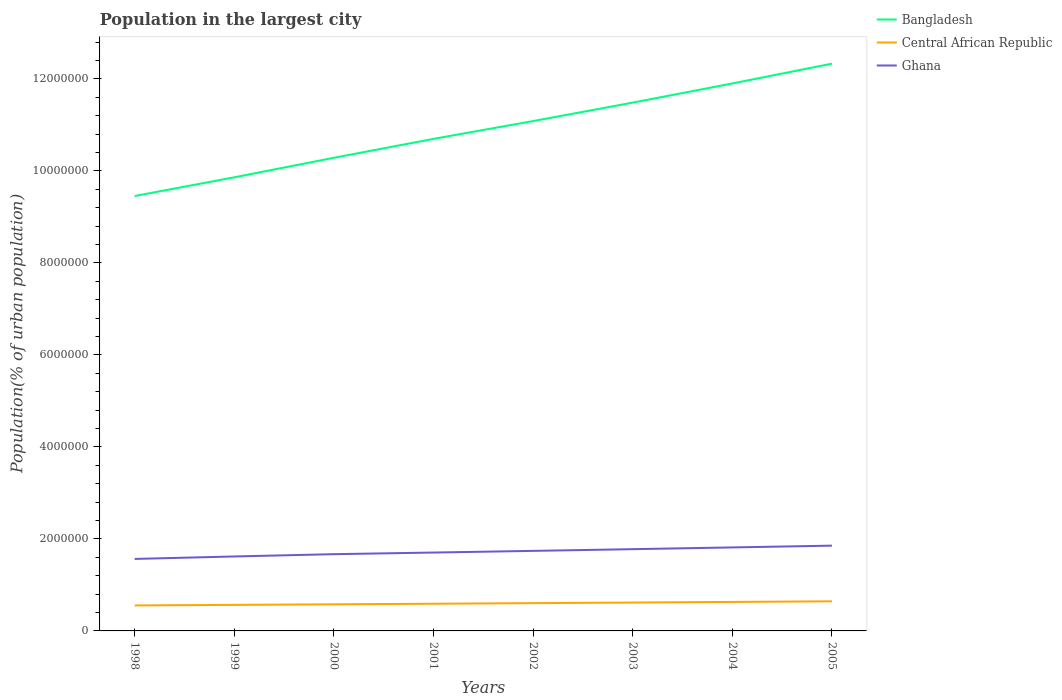How many different coloured lines are there?
Your answer should be very brief. 3. Across all years, what is the maximum population in the largest city in Central African Republic?
Offer a very short reply. 5.54e+05. In which year was the population in the largest city in Bangladesh maximum?
Offer a very short reply. 1998. What is the total population in the largest city in Bangladesh in the graph?
Your response must be concise. -4.01e+05. What is the difference between the highest and the second highest population in the largest city in Ghana?
Provide a short and direct response. 2.89e+05. What is the difference between the highest and the lowest population in the largest city in Bangladesh?
Ensure brevity in your answer.  4. Is the population in the largest city in Ghana strictly greater than the population in the largest city in Bangladesh over the years?
Your response must be concise. Yes. How many lines are there?
Provide a short and direct response. 3. What is the difference between two consecutive major ticks on the Y-axis?
Offer a very short reply. 2.00e+06. How many legend labels are there?
Provide a succinct answer. 3. How are the legend labels stacked?
Provide a succinct answer. Vertical. What is the title of the graph?
Give a very brief answer. Population in the largest city. What is the label or title of the Y-axis?
Make the answer very short. Population(% of urban population). What is the Population(% of urban population) of Bangladesh in 1998?
Ensure brevity in your answer.  9.45e+06. What is the Population(% of urban population) of Central African Republic in 1998?
Your response must be concise. 5.54e+05. What is the Population(% of urban population) in Ghana in 1998?
Provide a succinct answer. 1.57e+06. What is the Population(% of urban population) in Bangladesh in 1999?
Provide a short and direct response. 9.86e+06. What is the Population(% of urban population) of Central African Republic in 1999?
Your answer should be very brief. 5.66e+05. What is the Population(% of urban population) of Ghana in 1999?
Offer a very short reply. 1.62e+06. What is the Population(% of urban population) of Bangladesh in 2000?
Offer a very short reply. 1.03e+07. What is the Population(% of urban population) in Central African Republic in 2000?
Your answer should be very brief. 5.79e+05. What is the Population(% of urban population) in Ghana in 2000?
Your answer should be compact. 1.67e+06. What is the Population(% of urban population) in Bangladesh in 2001?
Provide a succinct answer. 1.07e+07. What is the Population(% of urban population) of Central African Republic in 2001?
Your answer should be very brief. 5.91e+05. What is the Population(% of urban population) in Ghana in 2001?
Provide a succinct answer. 1.70e+06. What is the Population(% of urban population) of Bangladesh in 2002?
Give a very brief answer. 1.11e+07. What is the Population(% of urban population) in Central African Republic in 2002?
Provide a short and direct response. 6.04e+05. What is the Population(% of urban population) of Ghana in 2002?
Ensure brevity in your answer.  1.74e+06. What is the Population(% of urban population) of Bangladesh in 2003?
Offer a very short reply. 1.15e+07. What is the Population(% of urban population) of Central African Republic in 2003?
Your answer should be very brief. 6.17e+05. What is the Population(% of urban population) of Ghana in 2003?
Keep it short and to the point. 1.78e+06. What is the Population(% of urban population) in Bangladesh in 2004?
Make the answer very short. 1.19e+07. What is the Population(% of urban population) in Central African Republic in 2004?
Your response must be concise. 6.30e+05. What is the Population(% of urban population) of Ghana in 2004?
Offer a terse response. 1.82e+06. What is the Population(% of urban population) of Bangladesh in 2005?
Provide a short and direct response. 1.23e+07. What is the Population(% of urban population) in Central African Republic in 2005?
Ensure brevity in your answer.  6.44e+05. What is the Population(% of urban population) in Ghana in 2005?
Offer a terse response. 1.85e+06. Across all years, what is the maximum Population(% of urban population) in Bangladesh?
Provide a succinct answer. 1.23e+07. Across all years, what is the maximum Population(% of urban population) in Central African Republic?
Your response must be concise. 6.44e+05. Across all years, what is the maximum Population(% of urban population) of Ghana?
Give a very brief answer. 1.85e+06. Across all years, what is the minimum Population(% of urban population) in Bangladesh?
Your answer should be compact. 9.45e+06. Across all years, what is the minimum Population(% of urban population) of Central African Republic?
Provide a succinct answer. 5.54e+05. Across all years, what is the minimum Population(% of urban population) of Ghana?
Give a very brief answer. 1.57e+06. What is the total Population(% of urban population) of Bangladesh in the graph?
Your response must be concise. 8.71e+07. What is the total Population(% of urban population) of Central African Republic in the graph?
Provide a succinct answer. 4.79e+06. What is the total Population(% of urban population) of Ghana in the graph?
Your answer should be very brief. 1.37e+07. What is the difference between the Population(% of urban population) of Bangladesh in 1998 and that in 1999?
Your answer should be compact. -4.06e+05. What is the difference between the Population(% of urban population) of Central African Republic in 1998 and that in 1999?
Your answer should be compact. -1.20e+04. What is the difference between the Population(% of urban population) of Ghana in 1998 and that in 1999?
Provide a short and direct response. -5.33e+04. What is the difference between the Population(% of urban population) of Bangladesh in 1998 and that in 2000?
Provide a succinct answer. -8.31e+05. What is the difference between the Population(% of urban population) of Central African Republic in 1998 and that in 2000?
Your answer should be compact. -2.43e+04. What is the difference between the Population(% of urban population) in Ghana in 1998 and that in 2000?
Offer a very short reply. -1.03e+05. What is the difference between the Population(% of urban population) of Bangladesh in 1998 and that in 2001?
Your answer should be compact. -1.24e+06. What is the difference between the Population(% of urban population) of Central African Republic in 1998 and that in 2001?
Ensure brevity in your answer.  -3.68e+04. What is the difference between the Population(% of urban population) in Ghana in 1998 and that in 2001?
Make the answer very short. -1.39e+05. What is the difference between the Population(% of urban population) of Bangladesh in 1998 and that in 2002?
Your response must be concise. -1.63e+06. What is the difference between the Population(% of urban population) in Central African Republic in 1998 and that in 2002?
Give a very brief answer. -4.96e+04. What is the difference between the Population(% of urban population) of Ghana in 1998 and that in 2002?
Offer a terse response. -1.75e+05. What is the difference between the Population(% of urban population) in Bangladesh in 1998 and that in 2003?
Make the answer very short. -2.03e+06. What is the difference between the Population(% of urban population) of Central African Republic in 1998 and that in 2003?
Provide a short and direct response. -6.27e+04. What is the difference between the Population(% of urban population) in Ghana in 1998 and that in 2003?
Provide a succinct answer. -2.12e+05. What is the difference between the Population(% of urban population) of Bangladesh in 1998 and that in 2004?
Provide a short and direct response. -2.45e+06. What is the difference between the Population(% of urban population) in Central African Republic in 1998 and that in 2004?
Keep it short and to the point. -7.61e+04. What is the difference between the Population(% of urban population) in Ghana in 1998 and that in 2004?
Keep it short and to the point. -2.50e+05. What is the difference between the Population(% of urban population) in Bangladesh in 1998 and that in 2005?
Your answer should be compact. -2.88e+06. What is the difference between the Population(% of urban population) in Central African Republic in 1998 and that in 2005?
Offer a terse response. -8.97e+04. What is the difference between the Population(% of urban population) in Ghana in 1998 and that in 2005?
Offer a terse response. -2.89e+05. What is the difference between the Population(% of urban population) in Bangladesh in 1999 and that in 2000?
Keep it short and to the point. -4.25e+05. What is the difference between the Population(% of urban population) in Central African Republic in 1999 and that in 2000?
Offer a terse response. -1.23e+04. What is the difference between the Population(% of urban population) in Ghana in 1999 and that in 2000?
Provide a short and direct response. -4.97e+04. What is the difference between the Population(% of urban population) of Bangladesh in 1999 and that in 2001?
Your response must be concise. -8.35e+05. What is the difference between the Population(% of urban population) in Central African Republic in 1999 and that in 2001?
Provide a succinct answer. -2.48e+04. What is the difference between the Population(% of urban population) in Ghana in 1999 and that in 2001?
Provide a succinct answer. -8.53e+04. What is the difference between the Population(% of urban population) in Bangladesh in 1999 and that in 2002?
Your answer should be compact. -1.22e+06. What is the difference between the Population(% of urban population) of Central African Republic in 1999 and that in 2002?
Ensure brevity in your answer.  -3.76e+04. What is the difference between the Population(% of urban population) in Ghana in 1999 and that in 2002?
Provide a short and direct response. -1.22e+05. What is the difference between the Population(% of urban population) in Bangladesh in 1999 and that in 2003?
Ensure brevity in your answer.  -1.62e+06. What is the difference between the Population(% of urban population) of Central African Republic in 1999 and that in 2003?
Ensure brevity in your answer.  -5.07e+04. What is the difference between the Population(% of urban population) in Ghana in 1999 and that in 2003?
Keep it short and to the point. -1.59e+05. What is the difference between the Population(% of urban population) of Bangladesh in 1999 and that in 2004?
Your response must be concise. -2.04e+06. What is the difference between the Population(% of urban population) of Central African Republic in 1999 and that in 2004?
Provide a short and direct response. -6.41e+04. What is the difference between the Population(% of urban population) in Ghana in 1999 and that in 2004?
Make the answer very short. -1.97e+05. What is the difference between the Population(% of urban population) in Bangladesh in 1999 and that in 2005?
Give a very brief answer. -2.47e+06. What is the difference between the Population(% of urban population) in Central African Republic in 1999 and that in 2005?
Provide a short and direct response. -7.77e+04. What is the difference between the Population(% of urban population) of Ghana in 1999 and that in 2005?
Your answer should be very brief. -2.35e+05. What is the difference between the Population(% of urban population) of Bangladesh in 2000 and that in 2001?
Your answer should be very brief. -4.11e+05. What is the difference between the Population(% of urban population) in Central African Republic in 2000 and that in 2001?
Your response must be concise. -1.25e+04. What is the difference between the Population(% of urban population) in Ghana in 2000 and that in 2001?
Offer a very short reply. -3.55e+04. What is the difference between the Population(% of urban population) of Bangladesh in 2000 and that in 2002?
Your answer should be very brief. -7.98e+05. What is the difference between the Population(% of urban population) in Central African Republic in 2000 and that in 2002?
Provide a succinct answer. -2.53e+04. What is the difference between the Population(% of urban population) of Ghana in 2000 and that in 2002?
Offer a terse response. -7.19e+04. What is the difference between the Population(% of urban population) of Bangladesh in 2000 and that in 2003?
Keep it short and to the point. -1.20e+06. What is the difference between the Population(% of urban population) of Central African Republic in 2000 and that in 2003?
Make the answer very short. -3.84e+04. What is the difference between the Population(% of urban population) in Ghana in 2000 and that in 2003?
Your response must be concise. -1.09e+05. What is the difference between the Population(% of urban population) of Bangladesh in 2000 and that in 2004?
Your answer should be compact. -1.62e+06. What is the difference between the Population(% of urban population) of Central African Republic in 2000 and that in 2004?
Offer a terse response. -5.18e+04. What is the difference between the Population(% of urban population) in Ghana in 2000 and that in 2004?
Your answer should be compact. -1.47e+05. What is the difference between the Population(% of urban population) of Bangladesh in 2000 and that in 2005?
Your answer should be compact. -2.05e+06. What is the difference between the Population(% of urban population) of Central African Republic in 2000 and that in 2005?
Your answer should be compact. -6.54e+04. What is the difference between the Population(% of urban population) in Ghana in 2000 and that in 2005?
Offer a very short reply. -1.86e+05. What is the difference between the Population(% of urban population) of Bangladesh in 2001 and that in 2002?
Offer a terse response. -3.87e+05. What is the difference between the Population(% of urban population) in Central African Republic in 2001 and that in 2002?
Offer a terse response. -1.28e+04. What is the difference between the Population(% of urban population) in Ghana in 2001 and that in 2002?
Keep it short and to the point. -3.63e+04. What is the difference between the Population(% of urban population) of Bangladesh in 2001 and that in 2003?
Offer a terse response. -7.88e+05. What is the difference between the Population(% of urban population) of Central African Republic in 2001 and that in 2003?
Offer a terse response. -2.59e+04. What is the difference between the Population(% of urban population) in Ghana in 2001 and that in 2003?
Ensure brevity in your answer.  -7.34e+04. What is the difference between the Population(% of urban population) of Bangladesh in 2001 and that in 2004?
Offer a terse response. -1.20e+06. What is the difference between the Population(% of urban population) of Central African Republic in 2001 and that in 2004?
Your response must be concise. -3.93e+04. What is the difference between the Population(% of urban population) in Ghana in 2001 and that in 2004?
Your response must be concise. -1.11e+05. What is the difference between the Population(% of urban population) in Bangladesh in 2001 and that in 2005?
Offer a terse response. -1.64e+06. What is the difference between the Population(% of urban population) of Central African Republic in 2001 and that in 2005?
Provide a short and direct response. -5.29e+04. What is the difference between the Population(% of urban population) in Ghana in 2001 and that in 2005?
Your answer should be very brief. -1.50e+05. What is the difference between the Population(% of urban population) of Bangladesh in 2002 and that in 2003?
Provide a short and direct response. -4.01e+05. What is the difference between the Population(% of urban population) in Central African Republic in 2002 and that in 2003?
Offer a terse response. -1.31e+04. What is the difference between the Population(% of urban population) in Ghana in 2002 and that in 2003?
Keep it short and to the point. -3.71e+04. What is the difference between the Population(% of urban population) in Bangladesh in 2002 and that in 2004?
Your answer should be very brief. -8.18e+05. What is the difference between the Population(% of urban population) in Central African Republic in 2002 and that in 2004?
Offer a very short reply. -2.65e+04. What is the difference between the Population(% of urban population) of Ghana in 2002 and that in 2004?
Ensure brevity in your answer.  -7.51e+04. What is the difference between the Population(% of urban population) in Bangladesh in 2002 and that in 2005?
Provide a short and direct response. -1.25e+06. What is the difference between the Population(% of urban population) of Central African Republic in 2002 and that in 2005?
Give a very brief answer. -4.01e+04. What is the difference between the Population(% of urban population) in Ghana in 2002 and that in 2005?
Keep it short and to the point. -1.14e+05. What is the difference between the Population(% of urban population) of Bangladesh in 2003 and that in 2004?
Your answer should be very brief. -4.16e+05. What is the difference between the Population(% of urban population) in Central African Republic in 2003 and that in 2004?
Offer a terse response. -1.34e+04. What is the difference between the Population(% of urban population) of Ghana in 2003 and that in 2004?
Offer a terse response. -3.80e+04. What is the difference between the Population(% of urban population) of Bangladesh in 2003 and that in 2005?
Offer a very short reply. -8.47e+05. What is the difference between the Population(% of urban population) of Central African Republic in 2003 and that in 2005?
Your response must be concise. -2.70e+04. What is the difference between the Population(% of urban population) in Ghana in 2003 and that in 2005?
Your answer should be very brief. -7.66e+04. What is the difference between the Population(% of urban population) in Bangladesh in 2004 and that in 2005?
Offer a very short reply. -4.30e+05. What is the difference between the Population(% of urban population) in Central African Republic in 2004 and that in 2005?
Your answer should be compact. -1.36e+04. What is the difference between the Population(% of urban population) in Ghana in 2004 and that in 2005?
Make the answer very short. -3.87e+04. What is the difference between the Population(% of urban population) of Bangladesh in 1998 and the Population(% of urban population) of Central African Republic in 1999?
Make the answer very short. 8.89e+06. What is the difference between the Population(% of urban population) in Bangladesh in 1998 and the Population(% of urban population) in Ghana in 1999?
Give a very brief answer. 7.84e+06. What is the difference between the Population(% of urban population) in Central African Republic in 1998 and the Population(% of urban population) in Ghana in 1999?
Offer a terse response. -1.06e+06. What is the difference between the Population(% of urban population) in Bangladesh in 1998 and the Population(% of urban population) in Central African Republic in 2000?
Offer a very short reply. 8.88e+06. What is the difference between the Population(% of urban population) of Bangladesh in 1998 and the Population(% of urban population) of Ghana in 2000?
Your answer should be very brief. 7.79e+06. What is the difference between the Population(% of urban population) in Central African Republic in 1998 and the Population(% of urban population) in Ghana in 2000?
Ensure brevity in your answer.  -1.11e+06. What is the difference between the Population(% of urban population) in Bangladesh in 1998 and the Population(% of urban population) in Central African Republic in 2001?
Ensure brevity in your answer.  8.86e+06. What is the difference between the Population(% of urban population) in Bangladesh in 1998 and the Population(% of urban population) in Ghana in 2001?
Give a very brief answer. 7.75e+06. What is the difference between the Population(% of urban population) in Central African Republic in 1998 and the Population(% of urban population) in Ghana in 2001?
Give a very brief answer. -1.15e+06. What is the difference between the Population(% of urban population) in Bangladesh in 1998 and the Population(% of urban population) in Central African Republic in 2002?
Make the answer very short. 8.85e+06. What is the difference between the Population(% of urban population) in Bangladesh in 1998 and the Population(% of urban population) in Ghana in 2002?
Give a very brief answer. 7.71e+06. What is the difference between the Population(% of urban population) in Central African Republic in 1998 and the Population(% of urban population) in Ghana in 2002?
Offer a terse response. -1.19e+06. What is the difference between the Population(% of urban population) of Bangladesh in 1998 and the Population(% of urban population) of Central African Republic in 2003?
Give a very brief answer. 8.84e+06. What is the difference between the Population(% of urban population) of Bangladesh in 1998 and the Population(% of urban population) of Ghana in 2003?
Your answer should be very brief. 7.68e+06. What is the difference between the Population(% of urban population) of Central African Republic in 1998 and the Population(% of urban population) of Ghana in 2003?
Your answer should be compact. -1.22e+06. What is the difference between the Population(% of urban population) in Bangladesh in 1998 and the Population(% of urban population) in Central African Republic in 2004?
Provide a succinct answer. 8.82e+06. What is the difference between the Population(% of urban population) in Bangladesh in 1998 and the Population(% of urban population) in Ghana in 2004?
Provide a short and direct response. 7.64e+06. What is the difference between the Population(% of urban population) in Central African Republic in 1998 and the Population(% of urban population) in Ghana in 2004?
Your response must be concise. -1.26e+06. What is the difference between the Population(% of urban population) in Bangladesh in 1998 and the Population(% of urban population) in Central African Republic in 2005?
Keep it short and to the point. 8.81e+06. What is the difference between the Population(% of urban population) of Bangladesh in 1998 and the Population(% of urban population) of Ghana in 2005?
Ensure brevity in your answer.  7.60e+06. What is the difference between the Population(% of urban population) in Central African Republic in 1998 and the Population(% of urban population) in Ghana in 2005?
Provide a succinct answer. -1.30e+06. What is the difference between the Population(% of urban population) in Bangladesh in 1999 and the Population(% of urban population) in Central African Republic in 2000?
Your answer should be very brief. 9.28e+06. What is the difference between the Population(% of urban population) of Bangladesh in 1999 and the Population(% of urban population) of Ghana in 2000?
Your answer should be very brief. 8.19e+06. What is the difference between the Population(% of urban population) in Central African Republic in 1999 and the Population(% of urban population) in Ghana in 2000?
Offer a very short reply. -1.10e+06. What is the difference between the Population(% of urban population) of Bangladesh in 1999 and the Population(% of urban population) of Central African Republic in 2001?
Keep it short and to the point. 9.27e+06. What is the difference between the Population(% of urban population) of Bangladesh in 1999 and the Population(% of urban population) of Ghana in 2001?
Your response must be concise. 8.16e+06. What is the difference between the Population(% of urban population) in Central African Republic in 1999 and the Population(% of urban population) in Ghana in 2001?
Your response must be concise. -1.14e+06. What is the difference between the Population(% of urban population) of Bangladesh in 1999 and the Population(% of urban population) of Central African Republic in 2002?
Your answer should be compact. 9.26e+06. What is the difference between the Population(% of urban population) in Bangladesh in 1999 and the Population(% of urban population) in Ghana in 2002?
Your answer should be compact. 8.12e+06. What is the difference between the Population(% of urban population) of Central African Republic in 1999 and the Population(% of urban population) of Ghana in 2002?
Provide a short and direct response. -1.17e+06. What is the difference between the Population(% of urban population) in Bangladesh in 1999 and the Population(% of urban population) in Central African Republic in 2003?
Ensure brevity in your answer.  9.24e+06. What is the difference between the Population(% of urban population) of Bangladesh in 1999 and the Population(% of urban population) of Ghana in 2003?
Provide a short and direct response. 8.08e+06. What is the difference between the Population(% of urban population) of Central African Republic in 1999 and the Population(% of urban population) of Ghana in 2003?
Your answer should be compact. -1.21e+06. What is the difference between the Population(% of urban population) of Bangladesh in 1999 and the Population(% of urban population) of Central African Republic in 2004?
Your answer should be very brief. 9.23e+06. What is the difference between the Population(% of urban population) in Bangladesh in 1999 and the Population(% of urban population) in Ghana in 2004?
Your answer should be very brief. 8.05e+06. What is the difference between the Population(% of urban population) in Central African Republic in 1999 and the Population(% of urban population) in Ghana in 2004?
Make the answer very short. -1.25e+06. What is the difference between the Population(% of urban population) of Bangladesh in 1999 and the Population(% of urban population) of Central African Republic in 2005?
Give a very brief answer. 9.22e+06. What is the difference between the Population(% of urban population) of Bangladesh in 1999 and the Population(% of urban population) of Ghana in 2005?
Keep it short and to the point. 8.01e+06. What is the difference between the Population(% of urban population) of Central African Republic in 1999 and the Population(% of urban population) of Ghana in 2005?
Make the answer very short. -1.29e+06. What is the difference between the Population(% of urban population) of Bangladesh in 2000 and the Population(% of urban population) of Central African Republic in 2001?
Give a very brief answer. 9.69e+06. What is the difference between the Population(% of urban population) of Bangladesh in 2000 and the Population(% of urban population) of Ghana in 2001?
Offer a terse response. 8.58e+06. What is the difference between the Population(% of urban population) of Central African Republic in 2000 and the Population(% of urban population) of Ghana in 2001?
Give a very brief answer. -1.13e+06. What is the difference between the Population(% of urban population) in Bangladesh in 2000 and the Population(% of urban population) in Central African Republic in 2002?
Provide a succinct answer. 9.68e+06. What is the difference between the Population(% of urban population) in Bangladesh in 2000 and the Population(% of urban population) in Ghana in 2002?
Provide a succinct answer. 8.54e+06. What is the difference between the Population(% of urban population) in Central African Republic in 2000 and the Population(% of urban population) in Ghana in 2002?
Offer a terse response. -1.16e+06. What is the difference between the Population(% of urban population) of Bangladesh in 2000 and the Population(% of urban population) of Central African Republic in 2003?
Your answer should be compact. 9.67e+06. What is the difference between the Population(% of urban population) of Bangladesh in 2000 and the Population(% of urban population) of Ghana in 2003?
Keep it short and to the point. 8.51e+06. What is the difference between the Population(% of urban population) of Central African Republic in 2000 and the Population(% of urban population) of Ghana in 2003?
Keep it short and to the point. -1.20e+06. What is the difference between the Population(% of urban population) of Bangladesh in 2000 and the Population(% of urban population) of Central African Republic in 2004?
Give a very brief answer. 9.65e+06. What is the difference between the Population(% of urban population) in Bangladesh in 2000 and the Population(% of urban population) in Ghana in 2004?
Your answer should be very brief. 8.47e+06. What is the difference between the Population(% of urban population) of Central African Republic in 2000 and the Population(% of urban population) of Ghana in 2004?
Ensure brevity in your answer.  -1.24e+06. What is the difference between the Population(% of urban population) in Bangladesh in 2000 and the Population(% of urban population) in Central African Republic in 2005?
Provide a short and direct response. 9.64e+06. What is the difference between the Population(% of urban population) of Bangladesh in 2000 and the Population(% of urban population) of Ghana in 2005?
Provide a succinct answer. 8.43e+06. What is the difference between the Population(% of urban population) in Central African Republic in 2000 and the Population(% of urban population) in Ghana in 2005?
Offer a very short reply. -1.28e+06. What is the difference between the Population(% of urban population) of Bangladesh in 2001 and the Population(% of urban population) of Central African Republic in 2002?
Provide a short and direct response. 1.01e+07. What is the difference between the Population(% of urban population) of Bangladesh in 2001 and the Population(% of urban population) of Ghana in 2002?
Offer a very short reply. 8.96e+06. What is the difference between the Population(% of urban population) in Central African Republic in 2001 and the Population(% of urban population) in Ghana in 2002?
Provide a succinct answer. -1.15e+06. What is the difference between the Population(% of urban population) of Bangladesh in 2001 and the Population(% of urban population) of Central African Republic in 2003?
Offer a terse response. 1.01e+07. What is the difference between the Population(% of urban population) in Bangladesh in 2001 and the Population(% of urban population) in Ghana in 2003?
Offer a terse response. 8.92e+06. What is the difference between the Population(% of urban population) in Central African Republic in 2001 and the Population(% of urban population) in Ghana in 2003?
Your answer should be very brief. -1.19e+06. What is the difference between the Population(% of urban population) of Bangladesh in 2001 and the Population(% of urban population) of Central African Republic in 2004?
Ensure brevity in your answer.  1.01e+07. What is the difference between the Population(% of urban population) of Bangladesh in 2001 and the Population(% of urban population) of Ghana in 2004?
Offer a very short reply. 8.88e+06. What is the difference between the Population(% of urban population) of Central African Republic in 2001 and the Population(% of urban population) of Ghana in 2004?
Your answer should be compact. -1.22e+06. What is the difference between the Population(% of urban population) of Bangladesh in 2001 and the Population(% of urban population) of Central African Republic in 2005?
Ensure brevity in your answer.  1.01e+07. What is the difference between the Population(% of urban population) in Bangladesh in 2001 and the Population(% of urban population) in Ghana in 2005?
Offer a very short reply. 8.84e+06. What is the difference between the Population(% of urban population) of Central African Republic in 2001 and the Population(% of urban population) of Ghana in 2005?
Keep it short and to the point. -1.26e+06. What is the difference between the Population(% of urban population) in Bangladesh in 2002 and the Population(% of urban population) in Central African Republic in 2003?
Give a very brief answer. 1.05e+07. What is the difference between the Population(% of urban population) in Bangladesh in 2002 and the Population(% of urban population) in Ghana in 2003?
Provide a succinct answer. 9.31e+06. What is the difference between the Population(% of urban population) of Central African Republic in 2002 and the Population(% of urban population) of Ghana in 2003?
Give a very brief answer. -1.17e+06. What is the difference between the Population(% of urban population) of Bangladesh in 2002 and the Population(% of urban population) of Central African Republic in 2004?
Offer a terse response. 1.05e+07. What is the difference between the Population(% of urban population) in Bangladesh in 2002 and the Population(% of urban population) in Ghana in 2004?
Offer a very short reply. 9.27e+06. What is the difference between the Population(% of urban population) in Central African Republic in 2002 and the Population(% of urban population) in Ghana in 2004?
Provide a succinct answer. -1.21e+06. What is the difference between the Population(% of urban population) in Bangladesh in 2002 and the Population(% of urban population) in Central African Republic in 2005?
Make the answer very short. 1.04e+07. What is the difference between the Population(% of urban population) in Bangladesh in 2002 and the Population(% of urban population) in Ghana in 2005?
Ensure brevity in your answer.  9.23e+06. What is the difference between the Population(% of urban population) of Central African Republic in 2002 and the Population(% of urban population) of Ghana in 2005?
Your answer should be very brief. -1.25e+06. What is the difference between the Population(% of urban population) of Bangladesh in 2003 and the Population(% of urban population) of Central African Republic in 2004?
Ensure brevity in your answer.  1.09e+07. What is the difference between the Population(% of urban population) in Bangladesh in 2003 and the Population(% of urban population) in Ghana in 2004?
Make the answer very short. 9.67e+06. What is the difference between the Population(% of urban population) in Central African Republic in 2003 and the Population(% of urban population) in Ghana in 2004?
Provide a short and direct response. -1.20e+06. What is the difference between the Population(% of urban population) in Bangladesh in 2003 and the Population(% of urban population) in Central African Republic in 2005?
Offer a very short reply. 1.08e+07. What is the difference between the Population(% of urban population) in Bangladesh in 2003 and the Population(% of urban population) in Ghana in 2005?
Give a very brief answer. 9.63e+06. What is the difference between the Population(% of urban population) in Central African Republic in 2003 and the Population(% of urban population) in Ghana in 2005?
Offer a terse response. -1.24e+06. What is the difference between the Population(% of urban population) of Bangladesh in 2004 and the Population(% of urban population) of Central African Republic in 2005?
Keep it short and to the point. 1.13e+07. What is the difference between the Population(% of urban population) in Bangladesh in 2004 and the Population(% of urban population) in Ghana in 2005?
Your answer should be very brief. 1.00e+07. What is the difference between the Population(% of urban population) in Central African Republic in 2004 and the Population(% of urban population) in Ghana in 2005?
Provide a short and direct response. -1.22e+06. What is the average Population(% of urban population) in Bangladesh per year?
Provide a short and direct response. 1.09e+07. What is the average Population(% of urban population) of Central African Republic per year?
Ensure brevity in your answer.  5.98e+05. What is the average Population(% of urban population) of Ghana per year?
Provide a succinct answer. 1.72e+06. In the year 1998, what is the difference between the Population(% of urban population) of Bangladesh and Population(% of urban population) of Central African Republic?
Make the answer very short. 8.90e+06. In the year 1998, what is the difference between the Population(% of urban population) in Bangladesh and Population(% of urban population) in Ghana?
Offer a terse response. 7.89e+06. In the year 1998, what is the difference between the Population(% of urban population) in Central African Republic and Population(% of urban population) in Ghana?
Offer a terse response. -1.01e+06. In the year 1999, what is the difference between the Population(% of urban population) of Bangladesh and Population(% of urban population) of Central African Republic?
Your response must be concise. 9.29e+06. In the year 1999, what is the difference between the Population(% of urban population) of Bangladesh and Population(% of urban population) of Ghana?
Your answer should be very brief. 8.24e+06. In the year 1999, what is the difference between the Population(% of urban population) in Central African Republic and Population(% of urban population) in Ghana?
Give a very brief answer. -1.05e+06. In the year 2000, what is the difference between the Population(% of urban population) in Bangladesh and Population(% of urban population) in Central African Republic?
Your response must be concise. 9.71e+06. In the year 2000, what is the difference between the Population(% of urban population) of Bangladesh and Population(% of urban population) of Ghana?
Offer a terse response. 8.62e+06. In the year 2000, what is the difference between the Population(% of urban population) of Central African Republic and Population(% of urban population) of Ghana?
Make the answer very short. -1.09e+06. In the year 2001, what is the difference between the Population(% of urban population) in Bangladesh and Population(% of urban population) in Central African Republic?
Your answer should be very brief. 1.01e+07. In the year 2001, what is the difference between the Population(% of urban population) of Bangladesh and Population(% of urban population) of Ghana?
Give a very brief answer. 8.99e+06. In the year 2001, what is the difference between the Population(% of urban population) of Central African Republic and Population(% of urban population) of Ghana?
Provide a succinct answer. -1.11e+06. In the year 2002, what is the difference between the Population(% of urban population) of Bangladesh and Population(% of urban population) of Central African Republic?
Your answer should be very brief. 1.05e+07. In the year 2002, what is the difference between the Population(% of urban population) in Bangladesh and Population(% of urban population) in Ghana?
Your response must be concise. 9.34e+06. In the year 2002, what is the difference between the Population(% of urban population) in Central African Republic and Population(% of urban population) in Ghana?
Your response must be concise. -1.14e+06. In the year 2003, what is the difference between the Population(% of urban population) in Bangladesh and Population(% of urban population) in Central African Republic?
Make the answer very short. 1.09e+07. In the year 2003, what is the difference between the Population(% of urban population) of Bangladesh and Population(% of urban population) of Ghana?
Your answer should be very brief. 9.71e+06. In the year 2003, what is the difference between the Population(% of urban population) of Central African Republic and Population(% of urban population) of Ghana?
Give a very brief answer. -1.16e+06. In the year 2004, what is the difference between the Population(% of urban population) of Bangladesh and Population(% of urban population) of Central African Republic?
Make the answer very short. 1.13e+07. In the year 2004, what is the difference between the Population(% of urban population) in Bangladesh and Population(% of urban population) in Ghana?
Make the answer very short. 1.01e+07. In the year 2004, what is the difference between the Population(% of urban population) in Central African Republic and Population(% of urban population) in Ghana?
Your answer should be very brief. -1.18e+06. In the year 2005, what is the difference between the Population(% of urban population) of Bangladesh and Population(% of urban population) of Central African Republic?
Your answer should be compact. 1.17e+07. In the year 2005, what is the difference between the Population(% of urban population) in Bangladesh and Population(% of urban population) in Ghana?
Your answer should be very brief. 1.05e+07. In the year 2005, what is the difference between the Population(% of urban population) of Central African Republic and Population(% of urban population) of Ghana?
Ensure brevity in your answer.  -1.21e+06. What is the ratio of the Population(% of urban population) of Bangladesh in 1998 to that in 1999?
Your answer should be compact. 0.96. What is the ratio of the Population(% of urban population) of Central African Republic in 1998 to that in 1999?
Offer a very short reply. 0.98. What is the ratio of the Population(% of urban population) of Ghana in 1998 to that in 1999?
Your answer should be compact. 0.97. What is the ratio of the Population(% of urban population) of Bangladesh in 1998 to that in 2000?
Your answer should be very brief. 0.92. What is the ratio of the Population(% of urban population) in Central African Republic in 1998 to that in 2000?
Provide a short and direct response. 0.96. What is the ratio of the Population(% of urban population) in Ghana in 1998 to that in 2000?
Provide a succinct answer. 0.94. What is the ratio of the Population(% of urban population) of Bangladesh in 1998 to that in 2001?
Your response must be concise. 0.88. What is the ratio of the Population(% of urban population) in Central African Republic in 1998 to that in 2001?
Your answer should be very brief. 0.94. What is the ratio of the Population(% of urban population) of Ghana in 1998 to that in 2001?
Give a very brief answer. 0.92. What is the ratio of the Population(% of urban population) in Bangladesh in 1998 to that in 2002?
Ensure brevity in your answer.  0.85. What is the ratio of the Population(% of urban population) in Central African Republic in 1998 to that in 2002?
Your answer should be very brief. 0.92. What is the ratio of the Population(% of urban population) of Ghana in 1998 to that in 2002?
Your response must be concise. 0.9. What is the ratio of the Population(% of urban population) of Bangladesh in 1998 to that in 2003?
Give a very brief answer. 0.82. What is the ratio of the Population(% of urban population) in Central African Republic in 1998 to that in 2003?
Your response must be concise. 0.9. What is the ratio of the Population(% of urban population) in Ghana in 1998 to that in 2003?
Ensure brevity in your answer.  0.88. What is the ratio of the Population(% of urban population) of Bangladesh in 1998 to that in 2004?
Offer a very short reply. 0.79. What is the ratio of the Population(% of urban population) in Central African Republic in 1998 to that in 2004?
Offer a very short reply. 0.88. What is the ratio of the Population(% of urban population) in Ghana in 1998 to that in 2004?
Give a very brief answer. 0.86. What is the ratio of the Population(% of urban population) of Bangladesh in 1998 to that in 2005?
Provide a succinct answer. 0.77. What is the ratio of the Population(% of urban population) of Central African Republic in 1998 to that in 2005?
Keep it short and to the point. 0.86. What is the ratio of the Population(% of urban population) in Ghana in 1998 to that in 2005?
Offer a very short reply. 0.84. What is the ratio of the Population(% of urban population) of Bangladesh in 1999 to that in 2000?
Ensure brevity in your answer.  0.96. What is the ratio of the Population(% of urban population) of Central African Republic in 1999 to that in 2000?
Your answer should be very brief. 0.98. What is the ratio of the Population(% of urban population) of Ghana in 1999 to that in 2000?
Provide a short and direct response. 0.97. What is the ratio of the Population(% of urban population) of Bangladesh in 1999 to that in 2001?
Your response must be concise. 0.92. What is the ratio of the Population(% of urban population) in Central African Republic in 1999 to that in 2001?
Give a very brief answer. 0.96. What is the ratio of the Population(% of urban population) in Ghana in 1999 to that in 2001?
Ensure brevity in your answer.  0.95. What is the ratio of the Population(% of urban population) of Bangladesh in 1999 to that in 2002?
Your response must be concise. 0.89. What is the ratio of the Population(% of urban population) in Central African Republic in 1999 to that in 2002?
Provide a succinct answer. 0.94. What is the ratio of the Population(% of urban population) of Ghana in 1999 to that in 2002?
Offer a terse response. 0.93. What is the ratio of the Population(% of urban population) in Bangladesh in 1999 to that in 2003?
Make the answer very short. 0.86. What is the ratio of the Population(% of urban population) in Central African Republic in 1999 to that in 2003?
Give a very brief answer. 0.92. What is the ratio of the Population(% of urban population) in Ghana in 1999 to that in 2003?
Give a very brief answer. 0.91. What is the ratio of the Population(% of urban population) in Bangladesh in 1999 to that in 2004?
Offer a terse response. 0.83. What is the ratio of the Population(% of urban population) in Central African Republic in 1999 to that in 2004?
Provide a short and direct response. 0.9. What is the ratio of the Population(% of urban population) in Ghana in 1999 to that in 2004?
Give a very brief answer. 0.89. What is the ratio of the Population(% of urban population) in Bangladesh in 1999 to that in 2005?
Give a very brief answer. 0.8. What is the ratio of the Population(% of urban population) in Central African Republic in 1999 to that in 2005?
Make the answer very short. 0.88. What is the ratio of the Population(% of urban population) in Ghana in 1999 to that in 2005?
Offer a very short reply. 0.87. What is the ratio of the Population(% of urban population) of Bangladesh in 2000 to that in 2001?
Keep it short and to the point. 0.96. What is the ratio of the Population(% of urban population) of Central African Republic in 2000 to that in 2001?
Ensure brevity in your answer.  0.98. What is the ratio of the Population(% of urban population) in Ghana in 2000 to that in 2001?
Provide a succinct answer. 0.98. What is the ratio of the Population(% of urban population) of Bangladesh in 2000 to that in 2002?
Offer a terse response. 0.93. What is the ratio of the Population(% of urban population) of Central African Republic in 2000 to that in 2002?
Keep it short and to the point. 0.96. What is the ratio of the Population(% of urban population) of Ghana in 2000 to that in 2002?
Make the answer very short. 0.96. What is the ratio of the Population(% of urban population) in Bangladesh in 2000 to that in 2003?
Offer a very short reply. 0.9. What is the ratio of the Population(% of urban population) of Central African Republic in 2000 to that in 2003?
Your response must be concise. 0.94. What is the ratio of the Population(% of urban population) of Ghana in 2000 to that in 2003?
Make the answer very short. 0.94. What is the ratio of the Population(% of urban population) of Bangladesh in 2000 to that in 2004?
Your answer should be compact. 0.86. What is the ratio of the Population(% of urban population) in Central African Republic in 2000 to that in 2004?
Your answer should be very brief. 0.92. What is the ratio of the Population(% of urban population) in Ghana in 2000 to that in 2004?
Offer a terse response. 0.92. What is the ratio of the Population(% of urban population) in Bangladesh in 2000 to that in 2005?
Make the answer very short. 0.83. What is the ratio of the Population(% of urban population) in Central African Republic in 2000 to that in 2005?
Your answer should be very brief. 0.9. What is the ratio of the Population(% of urban population) in Ghana in 2000 to that in 2005?
Provide a short and direct response. 0.9. What is the ratio of the Population(% of urban population) of Bangladesh in 2001 to that in 2002?
Give a very brief answer. 0.97. What is the ratio of the Population(% of urban population) of Central African Republic in 2001 to that in 2002?
Your answer should be compact. 0.98. What is the ratio of the Population(% of urban population) of Ghana in 2001 to that in 2002?
Your answer should be very brief. 0.98. What is the ratio of the Population(% of urban population) in Bangladesh in 2001 to that in 2003?
Offer a very short reply. 0.93. What is the ratio of the Population(% of urban population) in Central African Republic in 2001 to that in 2003?
Provide a short and direct response. 0.96. What is the ratio of the Population(% of urban population) of Ghana in 2001 to that in 2003?
Offer a terse response. 0.96. What is the ratio of the Population(% of urban population) in Bangladesh in 2001 to that in 2004?
Make the answer very short. 0.9. What is the ratio of the Population(% of urban population) of Central African Republic in 2001 to that in 2004?
Ensure brevity in your answer.  0.94. What is the ratio of the Population(% of urban population) in Ghana in 2001 to that in 2004?
Your answer should be compact. 0.94. What is the ratio of the Population(% of urban population) in Bangladesh in 2001 to that in 2005?
Keep it short and to the point. 0.87. What is the ratio of the Population(% of urban population) in Central African Republic in 2001 to that in 2005?
Offer a terse response. 0.92. What is the ratio of the Population(% of urban population) in Ghana in 2001 to that in 2005?
Make the answer very short. 0.92. What is the ratio of the Population(% of urban population) in Bangladesh in 2002 to that in 2003?
Your answer should be very brief. 0.97. What is the ratio of the Population(% of urban population) of Central African Republic in 2002 to that in 2003?
Your answer should be compact. 0.98. What is the ratio of the Population(% of urban population) in Ghana in 2002 to that in 2003?
Make the answer very short. 0.98. What is the ratio of the Population(% of urban population) of Bangladesh in 2002 to that in 2004?
Provide a short and direct response. 0.93. What is the ratio of the Population(% of urban population) in Central African Republic in 2002 to that in 2004?
Your response must be concise. 0.96. What is the ratio of the Population(% of urban population) of Ghana in 2002 to that in 2004?
Your answer should be very brief. 0.96. What is the ratio of the Population(% of urban population) in Bangladesh in 2002 to that in 2005?
Give a very brief answer. 0.9. What is the ratio of the Population(% of urban population) of Central African Republic in 2002 to that in 2005?
Give a very brief answer. 0.94. What is the ratio of the Population(% of urban population) in Ghana in 2002 to that in 2005?
Provide a short and direct response. 0.94. What is the ratio of the Population(% of urban population) of Bangladesh in 2003 to that in 2004?
Provide a succinct answer. 0.96. What is the ratio of the Population(% of urban population) of Central African Republic in 2003 to that in 2004?
Provide a succinct answer. 0.98. What is the ratio of the Population(% of urban population) of Ghana in 2003 to that in 2004?
Provide a short and direct response. 0.98. What is the ratio of the Population(% of urban population) in Bangladesh in 2003 to that in 2005?
Your answer should be very brief. 0.93. What is the ratio of the Population(% of urban population) in Central African Republic in 2003 to that in 2005?
Provide a succinct answer. 0.96. What is the ratio of the Population(% of urban population) in Ghana in 2003 to that in 2005?
Your answer should be compact. 0.96. What is the ratio of the Population(% of urban population) in Bangladesh in 2004 to that in 2005?
Offer a terse response. 0.97. What is the ratio of the Population(% of urban population) of Central African Republic in 2004 to that in 2005?
Provide a short and direct response. 0.98. What is the ratio of the Population(% of urban population) in Ghana in 2004 to that in 2005?
Your answer should be compact. 0.98. What is the difference between the highest and the second highest Population(% of urban population) of Bangladesh?
Your answer should be very brief. 4.30e+05. What is the difference between the highest and the second highest Population(% of urban population) of Central African Republic?
Provide a succinct answer. 1.36e+04. What is the difference between the highest and the second highest Population(% of urban population) of Ghana?
Offer a very short reply. 3.87e+04. What is the difference between the highest and the lowest Population(% of urban population) in Bangladesh?
Keep it short and to the point. 2.88e+06. What is the difference between the highest and the lowest Population(% of urban population) in Central African Republic?
Provide a succinct answer. 8.97e+04. What is the difference between the highest and the lowest Population(% of urban population) in Ghana?
Your response must be concise. 2.89e+05. 